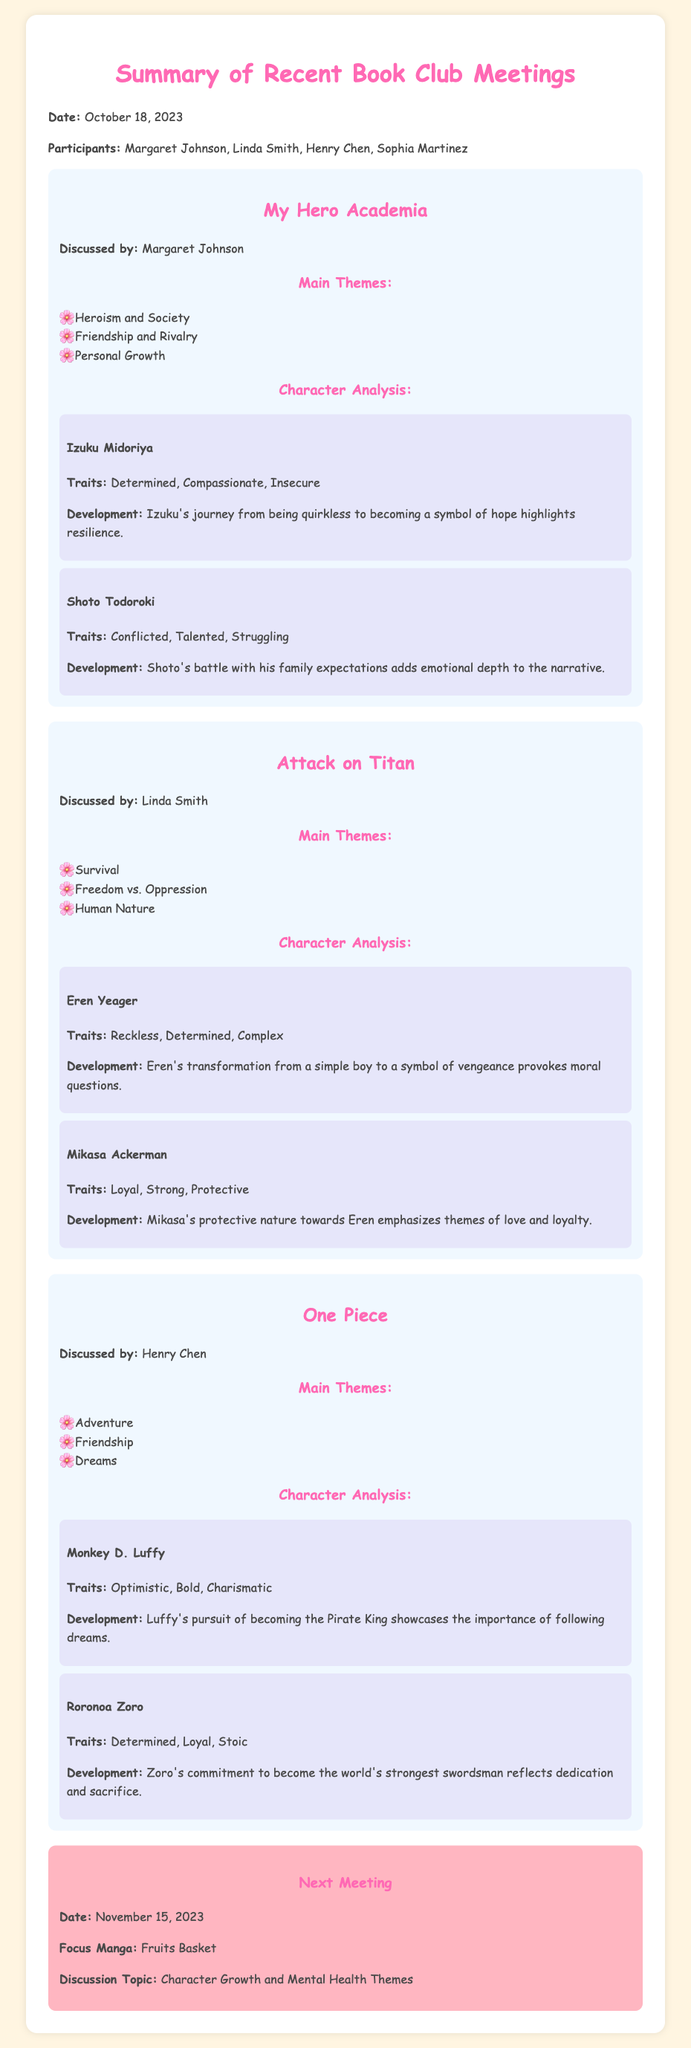What is the date of the latest book club meeting? The document lists the date of the meeting as October 18, 2023.
Answer: October 18, 2023 Who discussed My Hero Academia? The document specifies that Margaret Johnson discussed My Hero Academia.
Answer: Margaret Johnson What is the next focus manga for the book club? The document states that the focus manga for the next meeting is Fruits Basket.
Answer: Fruits Basket Which character's development emphasizes themes of love and loyalty? The analysis highlights Mikasa Ackerman's protective nature towards Eren as emphasizing themes of love and loyalty.
Answer: Mikasa Ackerman What are the main themes discussed for One Piece? The document lists Adventure, Friendship, and Dreams as the main themes for One Piece.
Answer: Adventure, Friendship, Dreams How many participants attended the recent meeting? The document lists four individuals as attending the meeting: Margaret Johnson, Linda Smith, Henry Chen, and Sophia Martinez.
Answer: Four What trait is associated with Eren Yeager? The document describes Eren Yeager as Reckless, Determined, and Complex.
Answer: Reckless What is the discussion topic for the next meeting? The document specifies the discussion topic for the next meeting as Character Growth and Mental Health Themes.
Answer: Character Growth and Mental Health Themes 